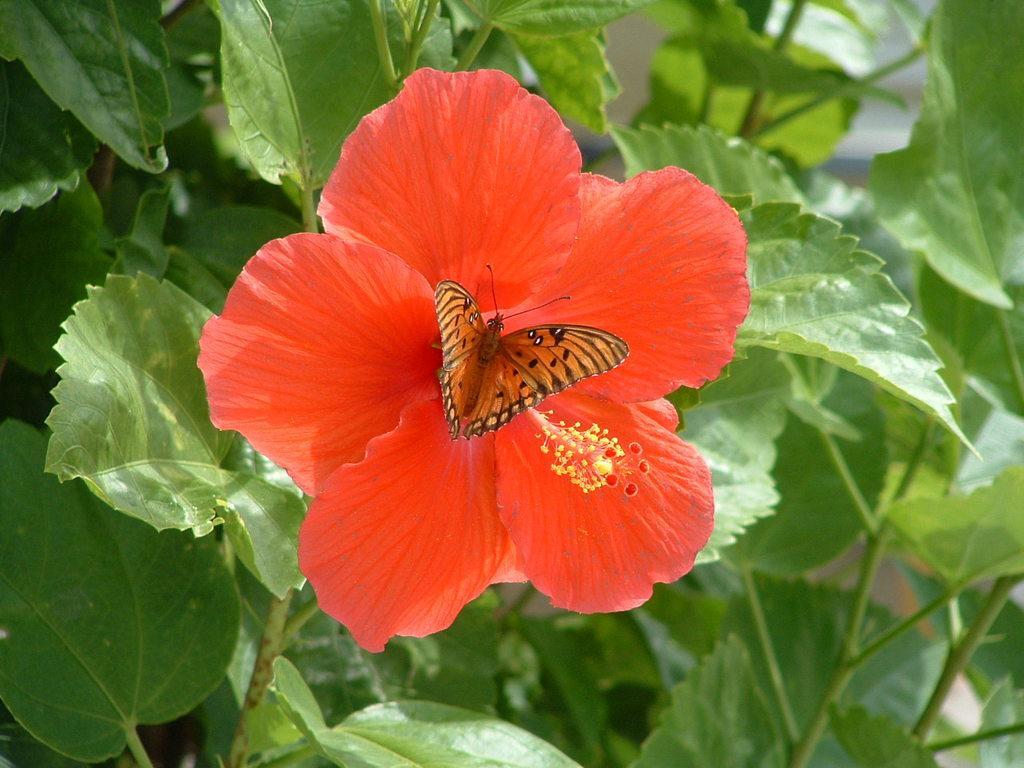How would you summarize this image in a sentence or two? In this image, we can see a butterfly on the flower. In the background, we can see some leaves. 